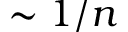<formula> <loc_0><loc_0><loc_500><loc_500>\sim 1 / n</formula> 